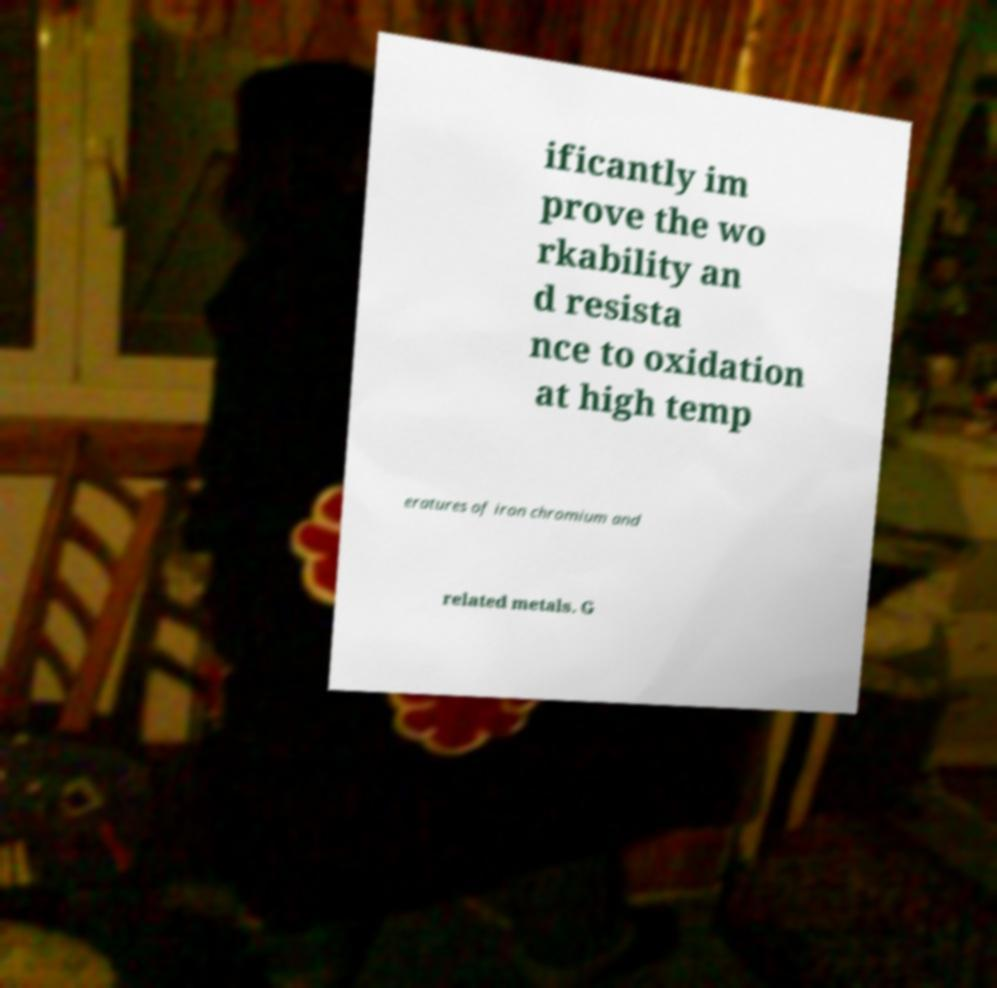I need the written content from this picture converted into text. Can you do that? ificantly im prove the wo rkability an d resista nce to oxidation at high temp eratures of iron chromium and related metals. G 